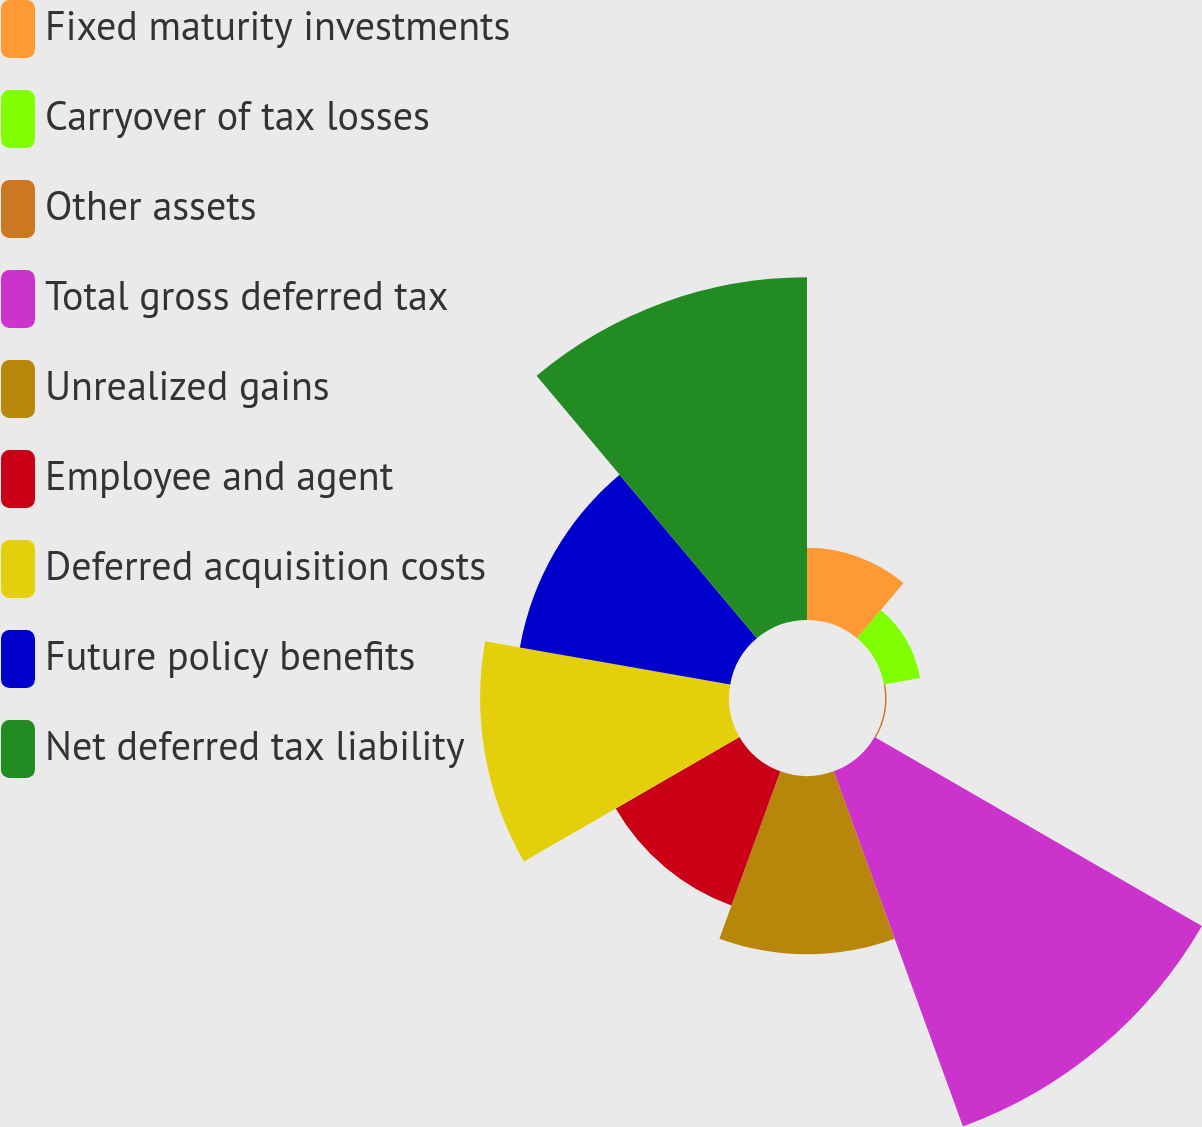Convert chart. <chart><loc_0><loc_0><loc_500><loc_500><pie_chart><fcel>Fixed maturity investments<fcel>Carryover of tax losses<fcel>Other assets<fcel>Total gross deferred tax<fcel>Unrealized gains<fcel>Employee and agent<fcel>Deferred acquisition costs<fcel>Future policy benefits<fcel>Net deferred tax liability<nl><fcel>4.47%<fcel>2.28%<fcel>0.09%<fcel>23.42%<fcel>11.04%<fcel>8.85%<fcel>15.42%<fcel>13.23%<fcel>21.23%<nl></chart> 